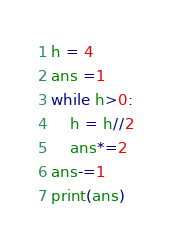<code> <loc_0><loc_0><loc_500><loc_500><_Python_>h = 4
ans =1
while h>0:
    h = h//2
    ans*=2
ans-=1
print(ans)
</code> 